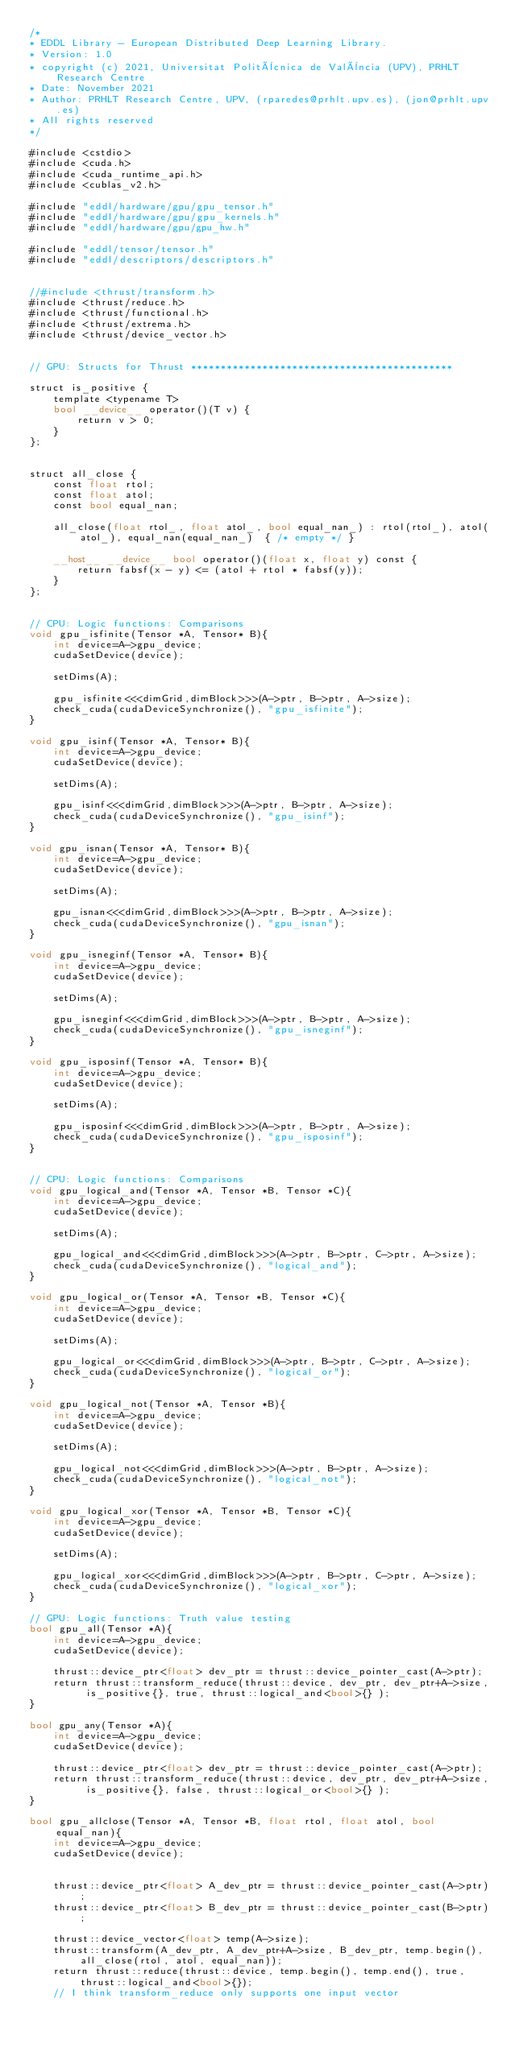<code> <loc_0><loc_0><loc_500><loc_500><_Cuda_>/*
* EDDL Library - European Distributed Deep Learning Library.
* Version: 1.0
* copyright (c) 2021, Universitat Politècnica de València (UPV), PRHLT Research Centre
* Date: November 2021
* Author: PRHLT Research Centre, UPV, (rparedes@prhlt.upv.es), (jon@prhlt.upv.es)
* All rights reserved
*/

#include <cstdio>
#include <cuda.h>
#include <cuda_runtime_api.h>
#include <cublas_v2.h>

#include "eddl/hardware/gpu/gpu_tensor.h"
#include "eddl/hardware/gpu/gpu_kernels.h"
#include "eddl/hardware/gpu/gpu_hw.h"

#include "eddl/tensor/tensor.h"
#include "eddl/descriptors/descriptors.h"


//#include <thrust/transform.h>
#include <thrust/reduce.h>
#include <thrust/functional.h>
#include <thrust/extrema.h>
#include <thrust/device_vector.h>


// GPU: Structs for Thrust ********************************************

struct is_positive {
    template <typename T>
    bool __device__ operator()(T v) {
        return v > 0;
    }
};


struct all_close {
    const float rtol;
    const float atol;
    const bool equal_nan;

    all_close(float rtol_, float atol_, bool equal_nan_) : rtol(rtol_), atol(atol_), equal_nan(equal_nan_)  { /* empty */ }

    __host__ __device__ bool operator()(float x, float y) const {
        return fabsf(x - y) <= (atol + rtol * fabsf(y));
    }
};


// CPU: Logic functions: Comparisons
void gpu_isfinite(Tensor *A, Tensor* B){
    int device=A->gpu_device;
    cudaSetDevice(device);

    setDims(A);

    gpu_isfinite<<<dimGrid,dimBlock>>>(A->ptr, B->ptr, A->size);
    check_cuda(cudaDeviceSynchronize(), "gpu_isfinite");
}

void gpu_isinf(Tensor *A, Tensor* B){
    int device=A->gpu_device;
    cudaSetDevice(device);

    setDims(A);

    gpu_isinf<<<dimGrid,dimBlock>>>(A->ptr, B->ptr, A->size);
    check_cuda(cudaDeviceSynchronize(), "gpu_isinf");
}

void gpu_isnan(Tensor *A, Tensor* B){
    int device=A->gpu_device;
    cudaSetDevice(device);

    setDims(A);

    gpu_isnan<<<dimGrid,dimBlock>>>(A->ptr, B->ptr, A->size);
    check_cuda(cudaDeviceSynchronize(), "gpu_isnan");
}

void gpu_isneginf(Tensor *A, Tensor* B){
    int device=A->gpu_device;
    cudaSetDevice(device);

    setDims(A);

    gpu_isneginf<<<dimGrid,dimBlock>>>(A->ptr, B->ptr, A->size);
    check_cuda(cudaDeviceSynchronize(), "gpu_isneginf");
}

void gpu_isposinf(Tensor *A, Tensor* B){
    int device=A->gpu_device;
    cudaSetDevice(device);

    setDims(A);

    gpu_isposinf<<<dimGrid,dimBlock>>>(A->ptr, B->ptr, A->size);
    check_cuda(cudaDeviceSynchronize(), "gpu_isposinf");
}


// CPU: Logic functions: Comparisons
void gpu_logical_and(Tensor *A, Tensor *B, Tensor *C){
    int device=A->gpu_device;
    cudaSetDevice(device);

    setDims(A);

    gpu_logical_and<<<dimGrid,dimBlock>>>(A->ptr, B->ptr, C->ptr, A->size);
    check_cuda(cudaDeviceSynchronize(), "logical_and");
}

void gpu_logical_or(Tensor *A, Tensor *B, Tensor *C){
    int device=A->gpu_device;
    cudaSetDevice(device);

    setDims(A);

    gpu_logical_or<<<dimGrid,dimBlock>>>(A->ptr, B->ptr, C->ptr, A->size);
    check_cuda(cudaDeviceSynchronize(), "logical_or");
}

void gpu_logical_not(Tensor *A, Tensor *B){
    int device=A->gpu_device;
    cudaSetDevice(device);

    setDims(A);

    gpu_logical_not<<<dimGrid,dimBlock>>>(A->ptr, B->ptr, A->size);
    check_cuda(cudaDeviceSynchronize(), "logical_not");
}

void gpu_logical_xor(Tensor *A, Tensor *B, Tensor *C){
    int device=A->gpu_device;
    cudaSetDevice(device);

    setDims(A);

    gpu_logical_xor<<<dimGrid,dimBlock>>>(A->ptr, B->ptr, C->ptr, A->size);
    check_cuda(cudaDeviceSynchronize(), "logical_xor");
}

// GPU: Logic functions: Truth value testing
bool gpu_all(Tensor *A){
    int device=A->gpu_device;
    cudaSetDevice(device);

    thrust::device_ptr<float> dev_ptr = thrust::device_pointer_cast(A->ptr);
    return thrust::transform_reduce(thrust::device, dev_ptr, dev_ptr+A->size, is_positive{}, true, thrust::logical_and<bool>{} );
}

bool gpu_any(Tensor *A){
    int device=A->gpu_device;
    cudaSetDevice(device);

    thrust::device_ptr<float> dev_ptr = thrust::device_pointer_cast(A->ptr);
    return thrust::transform_reduce(thrust::device, dev_ptr, dev_ptr+A->size, is_positive{}, false, thrust::logical_or<bool>{} );
}

bool gpu_allclose(Tensor *A, Tensor *B, float rtol, float atol, bool equal_nan){
    int device=A->gpu_device;
    cudaSetDevice(device);


    thrust::device_ptr<float> A_dev_ptr = thrust::device_pointer_cast(A->ptr);
    thrust::device_ptr<float> B_dev_ptr = thrust::device_pointer_cast(B->ptr);

    thrust::device_vector<float> temp(A->size);
    thrust::transform(A_dev_ptr, A_dev_ptr+A->size, B_dev_ptr, temp.begin(), all_close(rtol, atol, equal_nan));
    return thrust::reduce(thrust::device, temp.begin(), temp.end(), true, thrust::logical_and<bool>{});
    // I think transform_reduce only supports one input vector</code> 